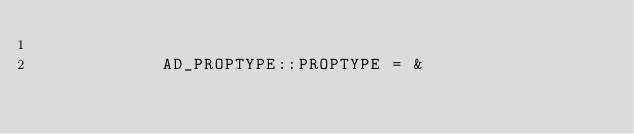<code> <loc_0><loc_0><loc_500><loc_500><_VisualBasic_>
			AD_PROPTYPE::PROPTYPE = &</code> 